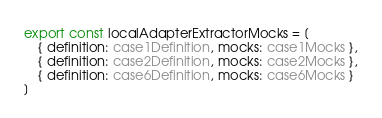<code> <loc_0><loc_0><loc_500><loc_500><_TypeScript_>export const localAdapterExtractorMocks = [
    { definition: case1Definition, mocks: case1Mocks },
    { definition: case2Definition, mocks: case2Mocks },
    { definition: case6Definition, mocks: case6Mocks }
]</code> 